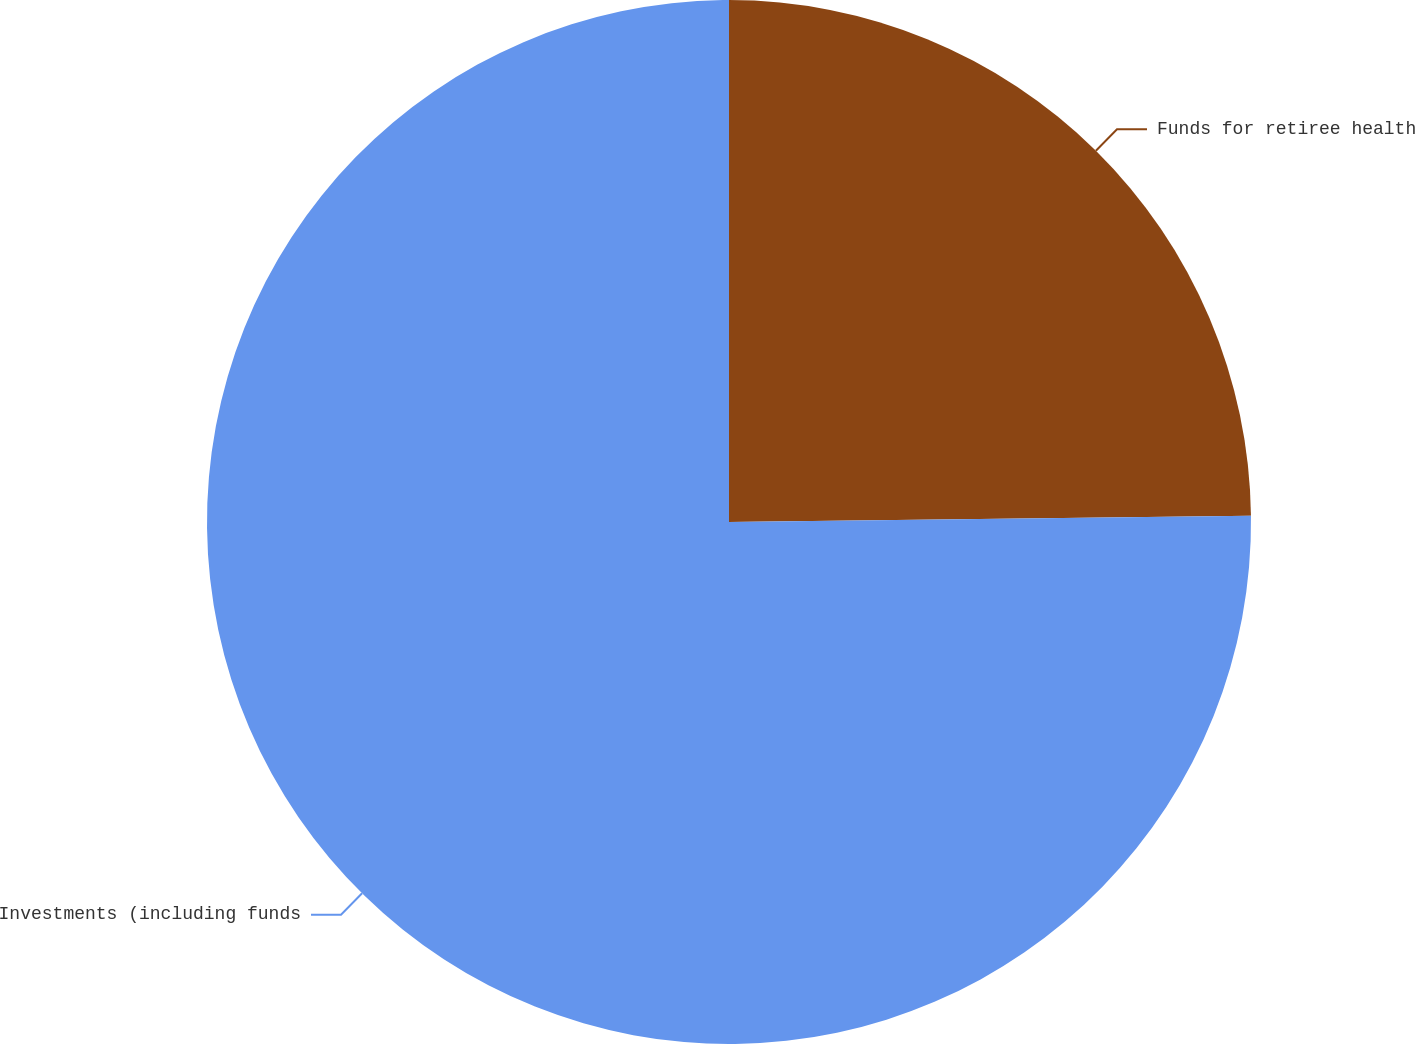Convert chart to OTSL. <chart><loc_0><loc_0><loc_500><loc_500><pie_chart><fcel>Funds for retiree health<fcel>Investments (including funds<nl><fcel>24.81%<fcel>75.19%<nl></chart> 